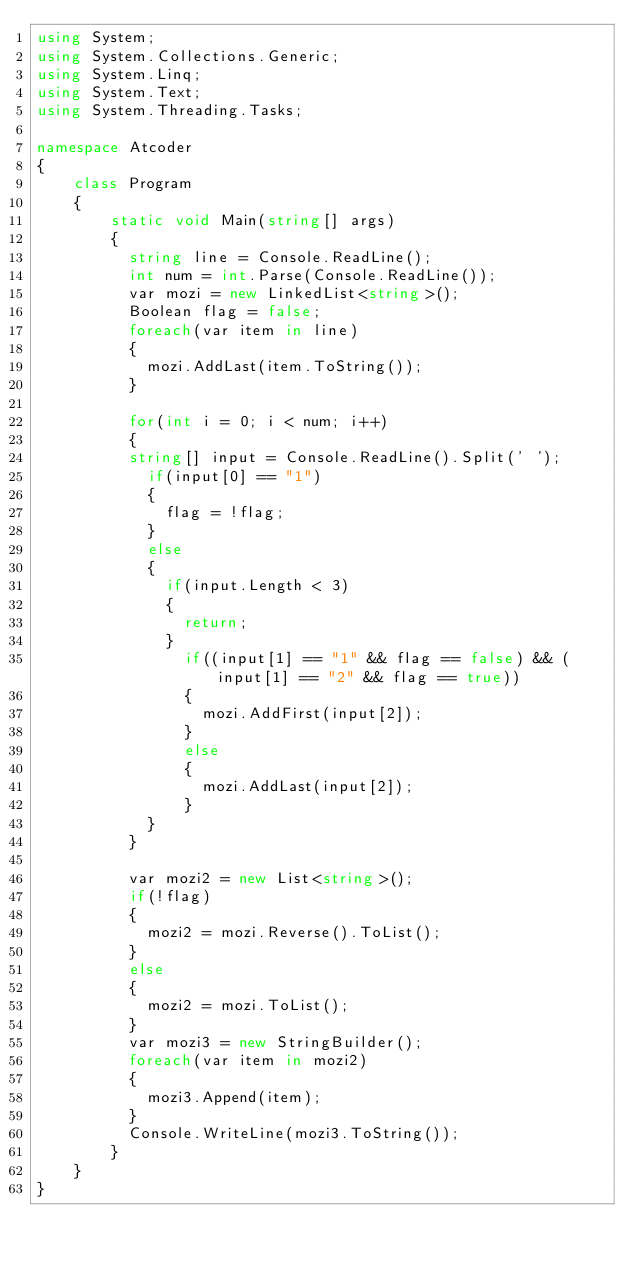Convert code to text. <code><loc_0><loc_0><loc_500><loc_500><_C#_>using System;
using System.Collections.Generic;
using System.Linq;
using System.Text;
using System.Threading.Tasks;
 
namespace Atcoder
{
    class Program
    { 
        static void Main(string[] args)
        {          
          string line = Console.ReadLine();
          int num = int.Parse(Console.ReadLine());
          var mozi = new LinkedList<string>();
          Boolean flag = false;
          foreach(var item in line)
          {
            mozi.AddLast(item.ToString());
          }
          
          for(int i = 0; i < num; i++)
          {
          string[] input = Console.ReadLine().Split(' ');
            if(input[0] == "1")
            {
              flag = !flag;
            }
            else 
            {
              if(input.Length < 3)
              {
                return;
              }
             	if((input[1] == "1" && flag == false) && (input[1] == "2" && flag == true))
                {
                  mozi.AddFirst(input[2]);
                }
              	else
                {
                  mozi.AddLast(input[2]);
                }
            }
          }
          
          var mozi2 = new List<string>();
          if(!flag)
          {
            mozi2 = mozi.Reverse().ToList();
          }
          else
          {
            mozi2 = mozi.ToList();
          }
          var mozi3 = new StringBuilder();
          foreach(var item in mozi2)
          {
            mozi3.Append(item);
          }
          Console.WriteLine(mozi3.ToString());
        }
    }
}
</code> 